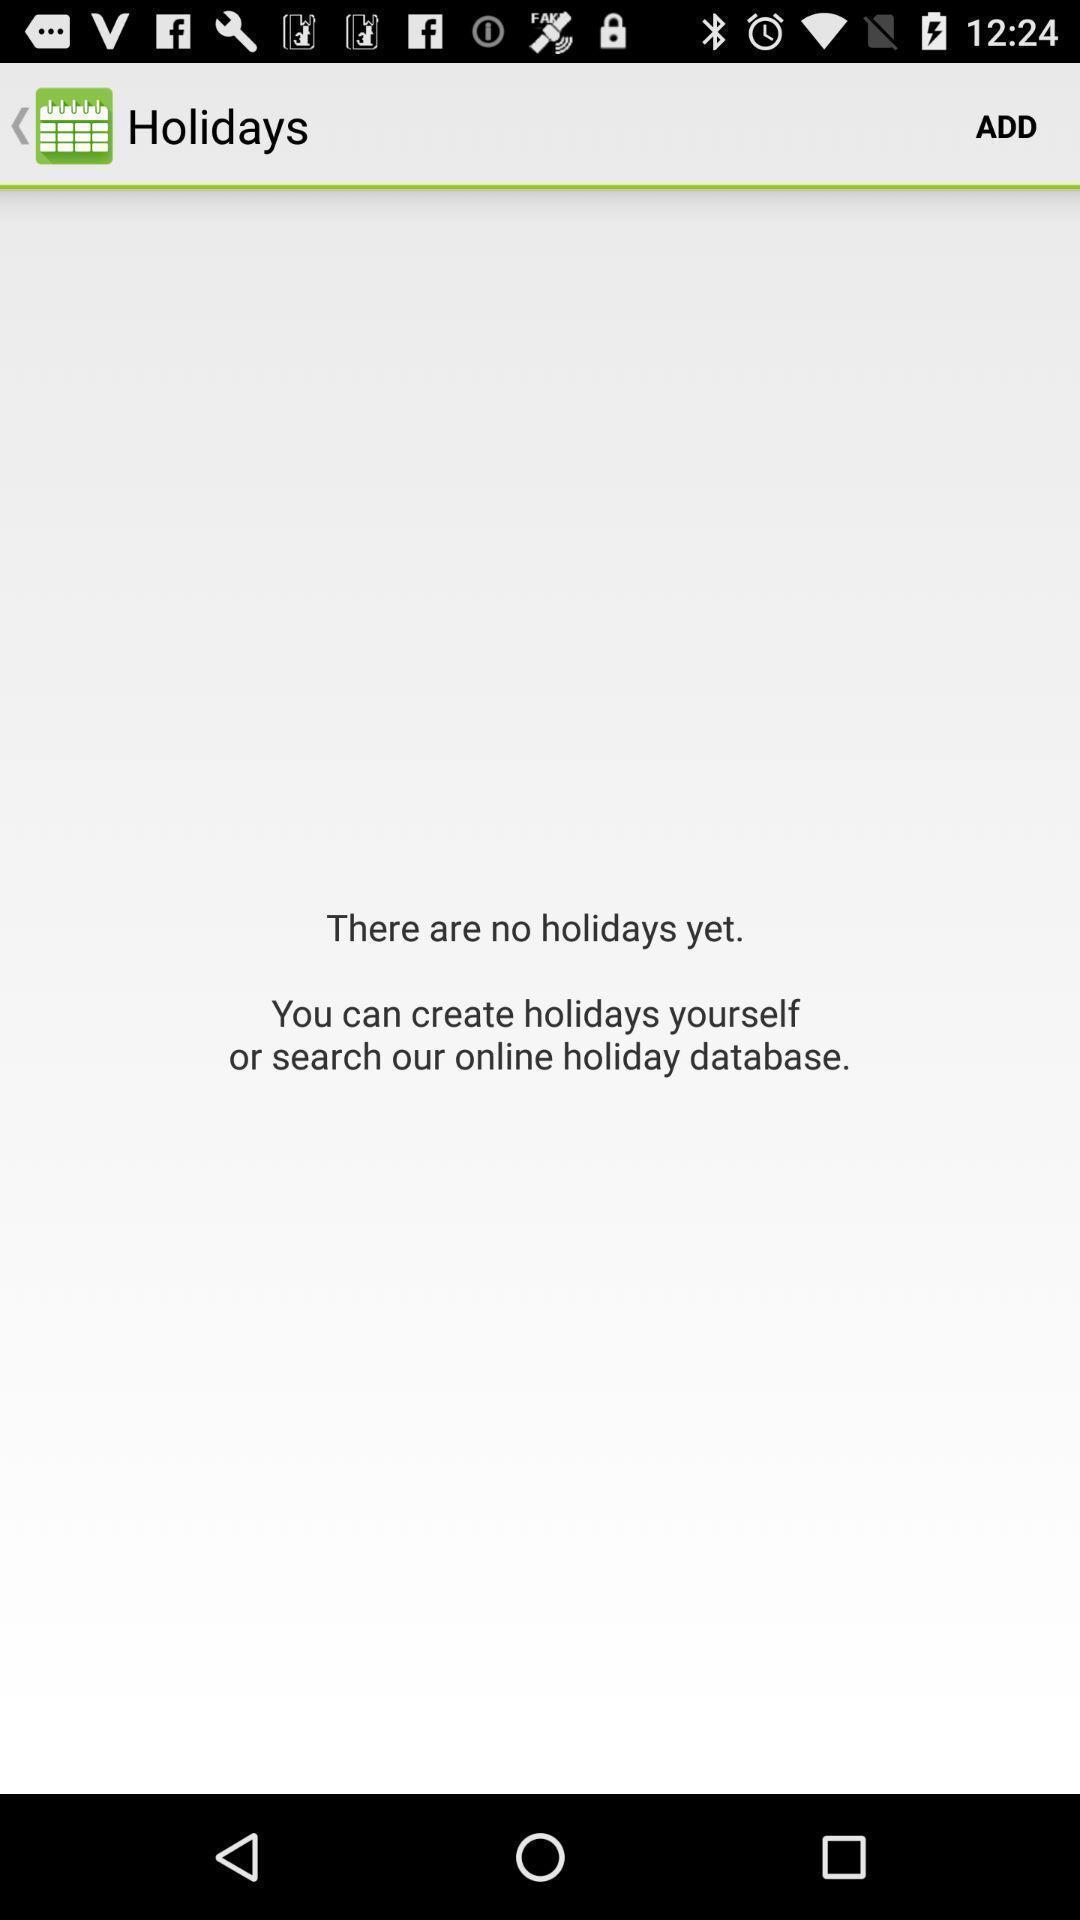Tell me about the visual elements in this screen capture. Page displaying holidays list on an app. 